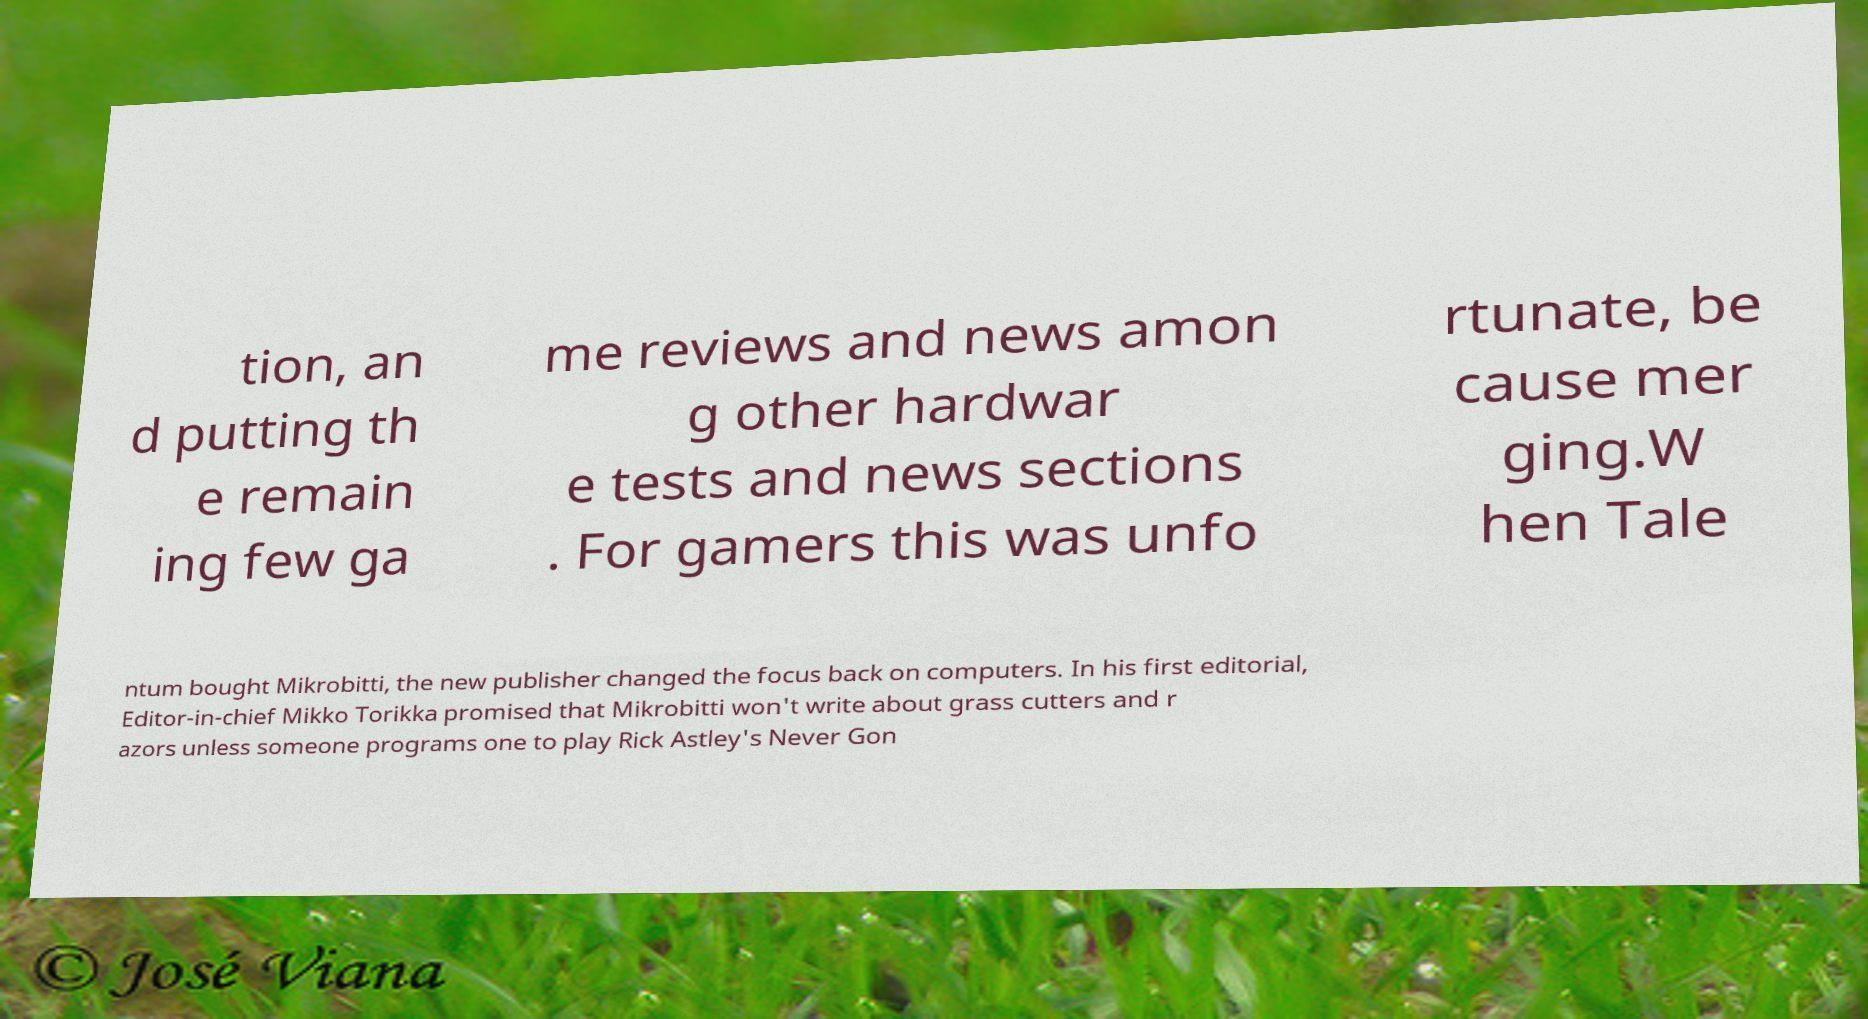For documentation purposes, I need the text within this image transcribed. Could you provide that? tion, an d putting th e remain ing few ga me reviews and news amon g other hardwar e tests and news sections . For gamers this was unfo rtunate, be cause mer ging.W hen Tale ntum bought Mikrobitti, the new publisher changed the focus back on computers. In his first editorial, Editor-in-chief Mikko Torikka promised that Mikrobitti won't write about grass cutters and r azors unless someone programs one to play Rick Astley's Never Gon 